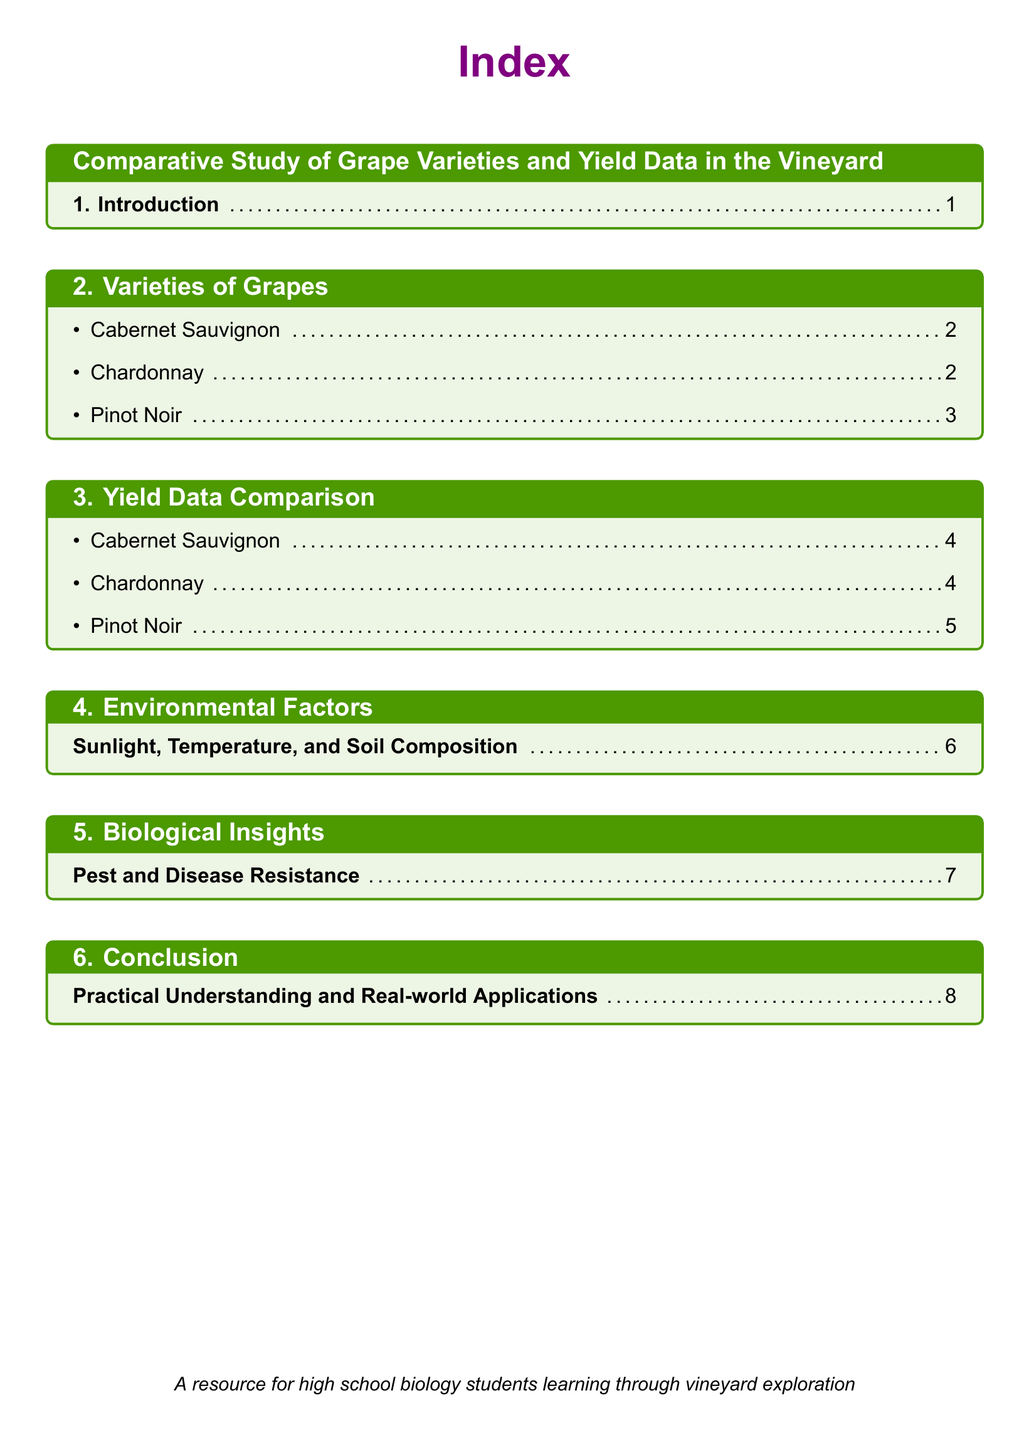What is the title of the document? The title is presented at the beginning of the document in a large font.
Answer: Comparative Study of Grape Varieties and Yield Data in the Vineyard How many grape varieties are mentioned? The number of grape varieties can be counted from the section list under "Varieties of Grapes."
Answer: 3 What is the first grape variety listed? The first item listed under "Varieties of Grapes" indicates the first grape variety.
Answer: Cabernet Sauvignon What page is the yield data for Chardonnay located on? The page number is provided next to each item under "Yield Data Comparison."
Answer: 4 Which section discusses environmental factors? The title of the section on environmental factors is explicitly mentioned in the index.
Answer: Environmental Factors What key topic is covered under Biological Insights? The key topic can be found in the title of the section dedicated to biological insights.
Answer: Pest and Disease Resistance On what page is the conclusion found? The document lists the page number for the conclusion section in the index.
Answer: 8 Which grape variety has data on page 5? The document indicates the page number next to each grape variety in the yield data section.
Answer: Pinot Noir What is the color used for section titles? The color for section titles can be inferred from the text formatting used in the document.
Answer: Vinegreen 